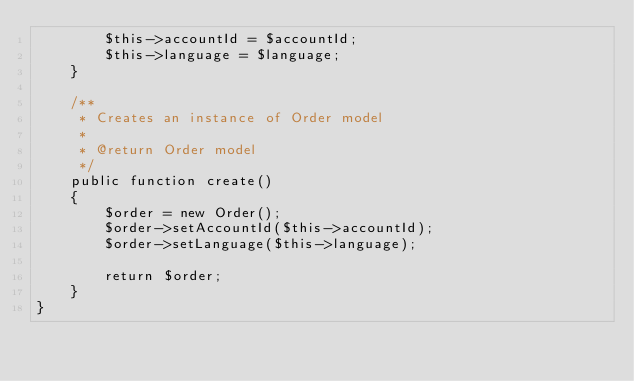Convert code to text. <code><loc_0><loc_0><loc_500><loc_500><_PHP_>        $this->accountId = $accountId;
        $this->language = $language;
    }

    /**
     * Creates an instance of Order model
     *
     * @return Order model
     */
    public function create()
    {
        $order = new Order();
        $order->setAccountId($this->accountId);
        $order->setLanguage($this->language);

        return $order;
    }
}
</code> 